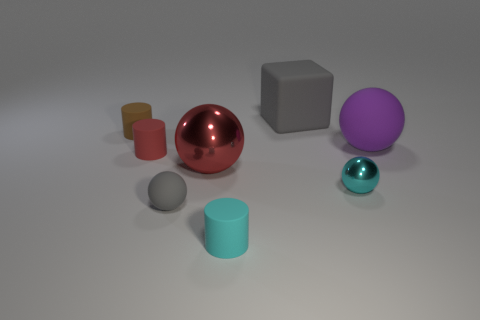Subtract all brown cylinders. How many cylinders are left? 2 Add 1 large gray rubber things. How many objects exist? 9 Subtract all cubes. How many objects are left? 7 Subtract 0 yellow cylinders. How many objects are left? 8 Subtract 2 spheres. How many spheres are left? 2 Subtract all cyan spheres. Subtract all yellow cubes. How many spheres are left? 3 Subtract all big gray matte spheres. Subtract all red things. How many objects are left? 6 Add 3 gray objects. How many gray objects are left? 5 Add 5 small cylinders. How many small cylinders exist? 8 Subtract all red cylinders. How many cylinders are left? 2 